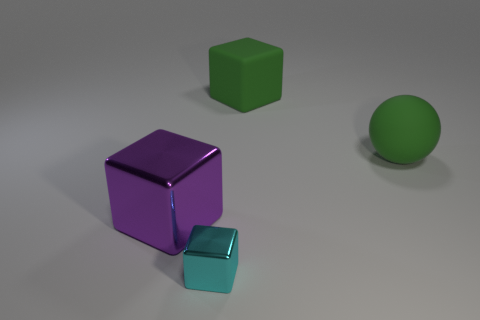Are there fewer large metallic cubes right of the cyan block than large things in front of the matte ball?
Your answer should be compact. Yes. Is the shape of the tiny cyan metal thing the same as the purple thing?
Make the answer very short. Yes. What number of other things are the same size as the sphere?
Keep it short and to the point. 2. What number of objects are things that are on the right side of the cyan shiny object or matte objects that are behind the large matte ball?
Offer a very short reply. 2. What number of other small brown metallic things have the same shape as the tiny metal thing?
Offer a terse response. 0. There is a large object that is both in front of the large green cube and to the left of the big sphere; what is it made of?
Provide a short and direct response. Metal. How many large blocks are in front of the big ball?
Your answer should be compact. 1. What number of tiny cyan blocks are there?
Offer a very short reply. 1. Is the green sphere the same size as the purple metallic object?
Provide a succinct answer. Yes. Are there any rubber things to the left of the big block to the right of the cyan metal block in front of the large purple object?
Keep it short and to the point. No. 